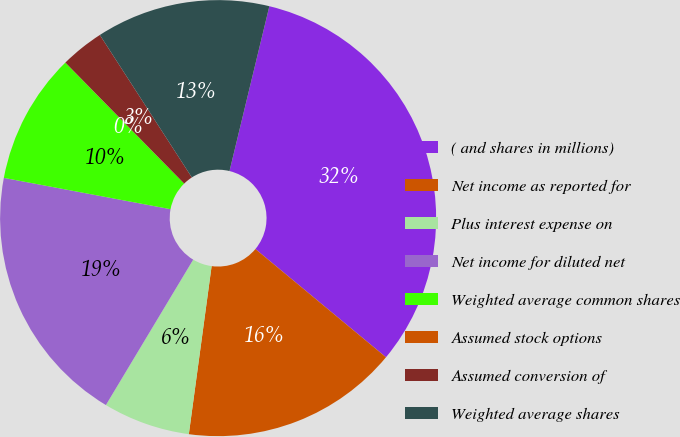Convert chart to OTSL. <chart><loc_0><loc_0><loc_500><loc_500><pie_chart><fcel>( and shares in millions)<fcel>Net income as reported for<fcel>Plus interest expense on<fcel>Net income for diluted net<fcel>Weighted average common shares<fcel>Assumed stock options<fcel>Assumed conversion of<fcel>Weighted average shares<nl><fcel>32.24%<fcel>16.13%<fcel>6.46%<fcel>19.35%<fcel>9.68%<fcel>0.01%<fcel>3.23%<fcel>12.9%<nl></chart> 